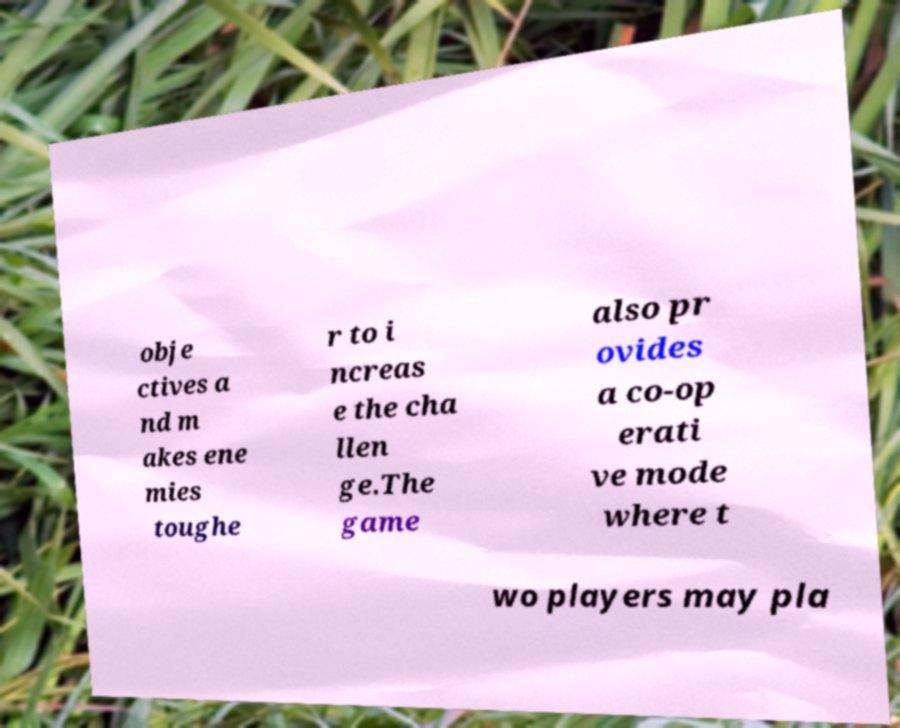There's text embedded in this image that I need extracted. Can you transcribe it verbatim? obje ctives a nd m akes ene mies toughe r to i ncreas e the cha llen ge.The game also pr ovides a co-op erati ve mode where t wo players may pla 